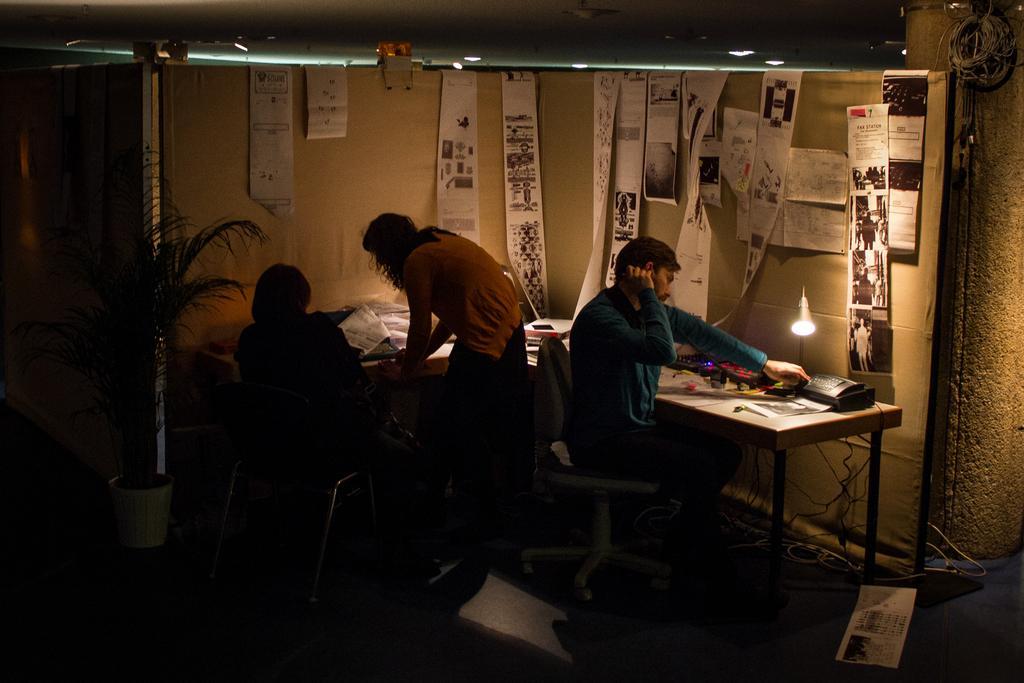Can you describe this image briefly? In this picture we can see two persons are sitting on the chairs and one is standing on the floor. And there is a plant. This is the table. And there is a light. On the background we can see the wall, and these are the posters on to the wall. 